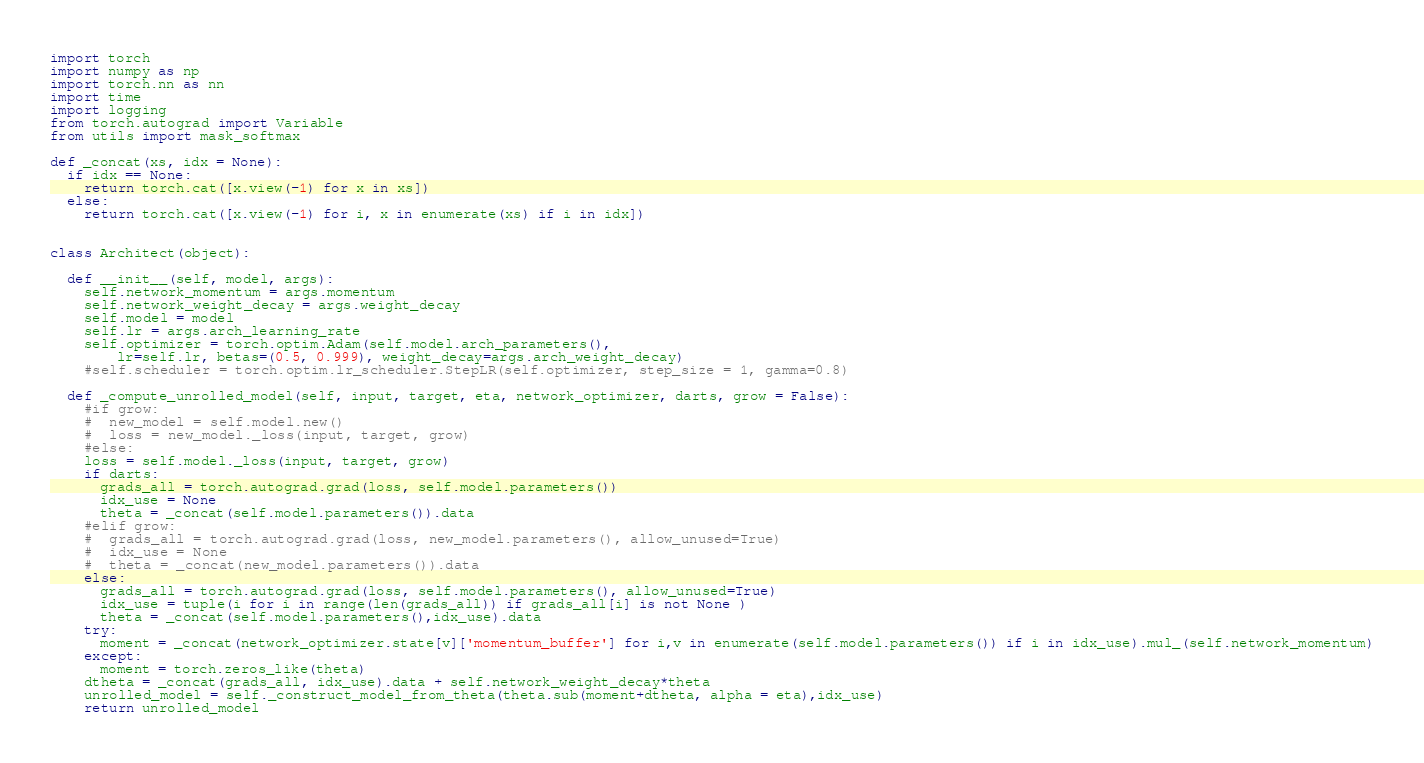Convert code to text. <code><loc_0><loc_0><loc_500><loc_500><_Python_>import torch
import numpy as np
import torch.nn as nn
import time
import logging
from torch.autograd import Variable
from utils import mask_softmax

def _concat(xs, idx = None):
  if idx == None:
    return torch.cat([x.view(-1) for x in xs])
  else:
    return torch.cat([x.view(-1) for i, x in enumerate(xs) if i in idx])


class Architect(object):

  def __init__(self, model, args):
    self.network_momentum = args.momentum
    self.network_weight_decay = args.weight_decay
    self.model = model
    self.lr = args.arch_learning_rate
    self.optimizer = torch.optim.Adam(self.model.arch_parameters(),
        lr=self.lr, betas=(0.5, 0.999), weight_decay=args.arch_weight_decay)
    #self.scheduler = torch.optim.lr_scheduler.StepLR(self.optimizer, step_size = 1, gamma=0.8)

  def _compute_unrolled_model(self, input, target, eta, network_optimizer, darts, grow = False):
    #if grow:
    #  new_model = self.model.new()
    #  loss = new_model._loss(input, target, grow)
    #else:
    loss = self.model._loss(input, target, grow)
    if darts:
      grads_all = torch.autograd.grad(loss, self.model.parameters())
      idx_use = None
      theta = _concat(self.model.parameters()).data
    #elif grow:
    #  grads_all = torch.autograd.grad(loss, new_model.parameters(), allow_unused=True)
    #  idx_use = None
    #  theta = _concat(new_model.parameters()).data
    else:
      grads_all = torch.autograd.grad(loss, self.model.parameters(), allow_unused=True)
      idx_use = tuple(i for i in range(len(grads_all)) if grads_all[i] is not None )
      theta = _concat(self.model.parameters(),idx_use).data
    try:
      moment = _concat(network_optimizer.state[v]['momentum_buffer'] for i,v in enumerate(self.model.parameters()) if i in idx_use).mul_(self.network_momentum)
    except:
      moment = torch.zeros_like(theta)
    dtheta = _concat(grads_all, idx_use).data + self.network_weight_decay*theta
    unrolled_model = self._construct_model_from_theta(theta.sub(moment+dtheta, alpha = eta),idx_use)
    return unrolled_model
</code> 